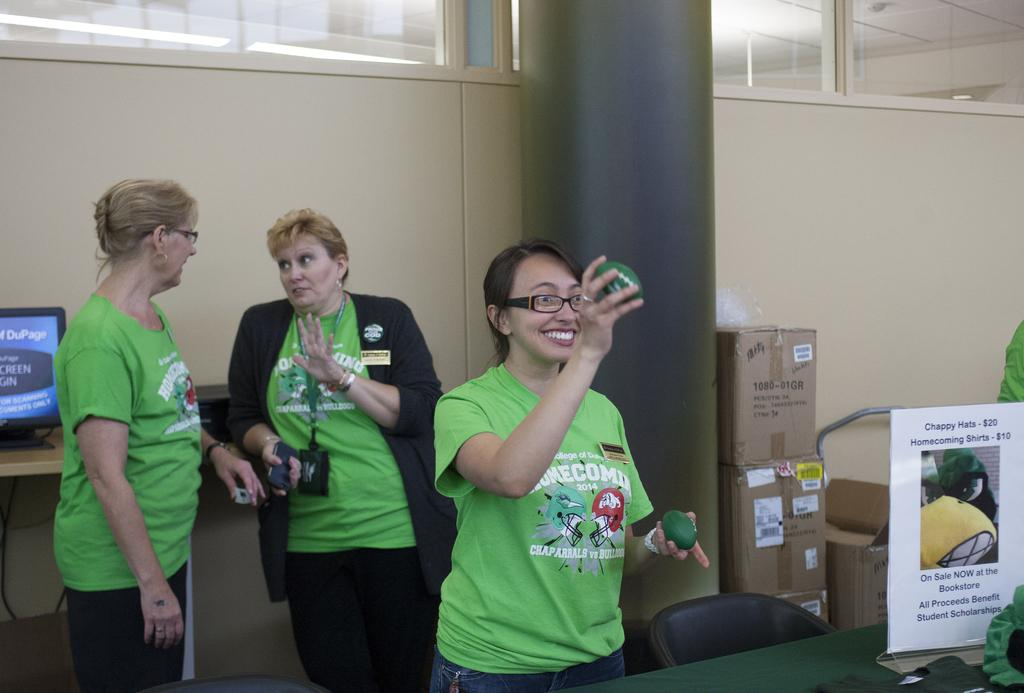Who is the main subject in the image? There is a woman in the image. What is the woman wearing? The woman is wearing a green dress. What is the woman holding in her hands? The woman is holding green objects in her hands. Are there any other people in the image? Yes, there are two other women standing behind her. What type of needle is the woman using to sew in the image? There is no needle present in the image; the woman is holding green objects, not a needle. 